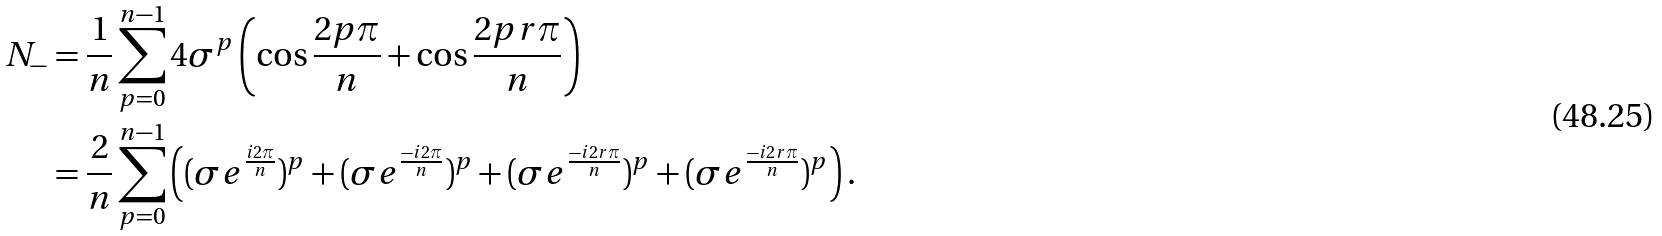Convert formula to latex. <formula><loc_0><loc_0><loc_500><loc_500>N _ { - } & = \frac { 1 } { n } \sum _ { p = 0 } ^ { n - 1 } 4 \sigma ^ { p } \left ( \cos \frac { 2 p \pi } { n } + \cos \frac { 2 p r \pi } { n } \right ) \\ & = \frac { 2 } { n } \sum _ { p = 0 } ^ { n - 1 } \left ( ( \sigma e ^ { \frac { i 2 \pi } { n } } ) ^ { p } + ( \sigma e ^ { \frac { - i 2 \pi } { n } } ) ^ { p } + ( \sigma e ^ { \frac { - i 2 r \pi } { n } } ) ^ { p } + ( \sigma e ^ { \frac { - i 2 r \pi } { n } } ) ^ { p } \right ) .</formula> 